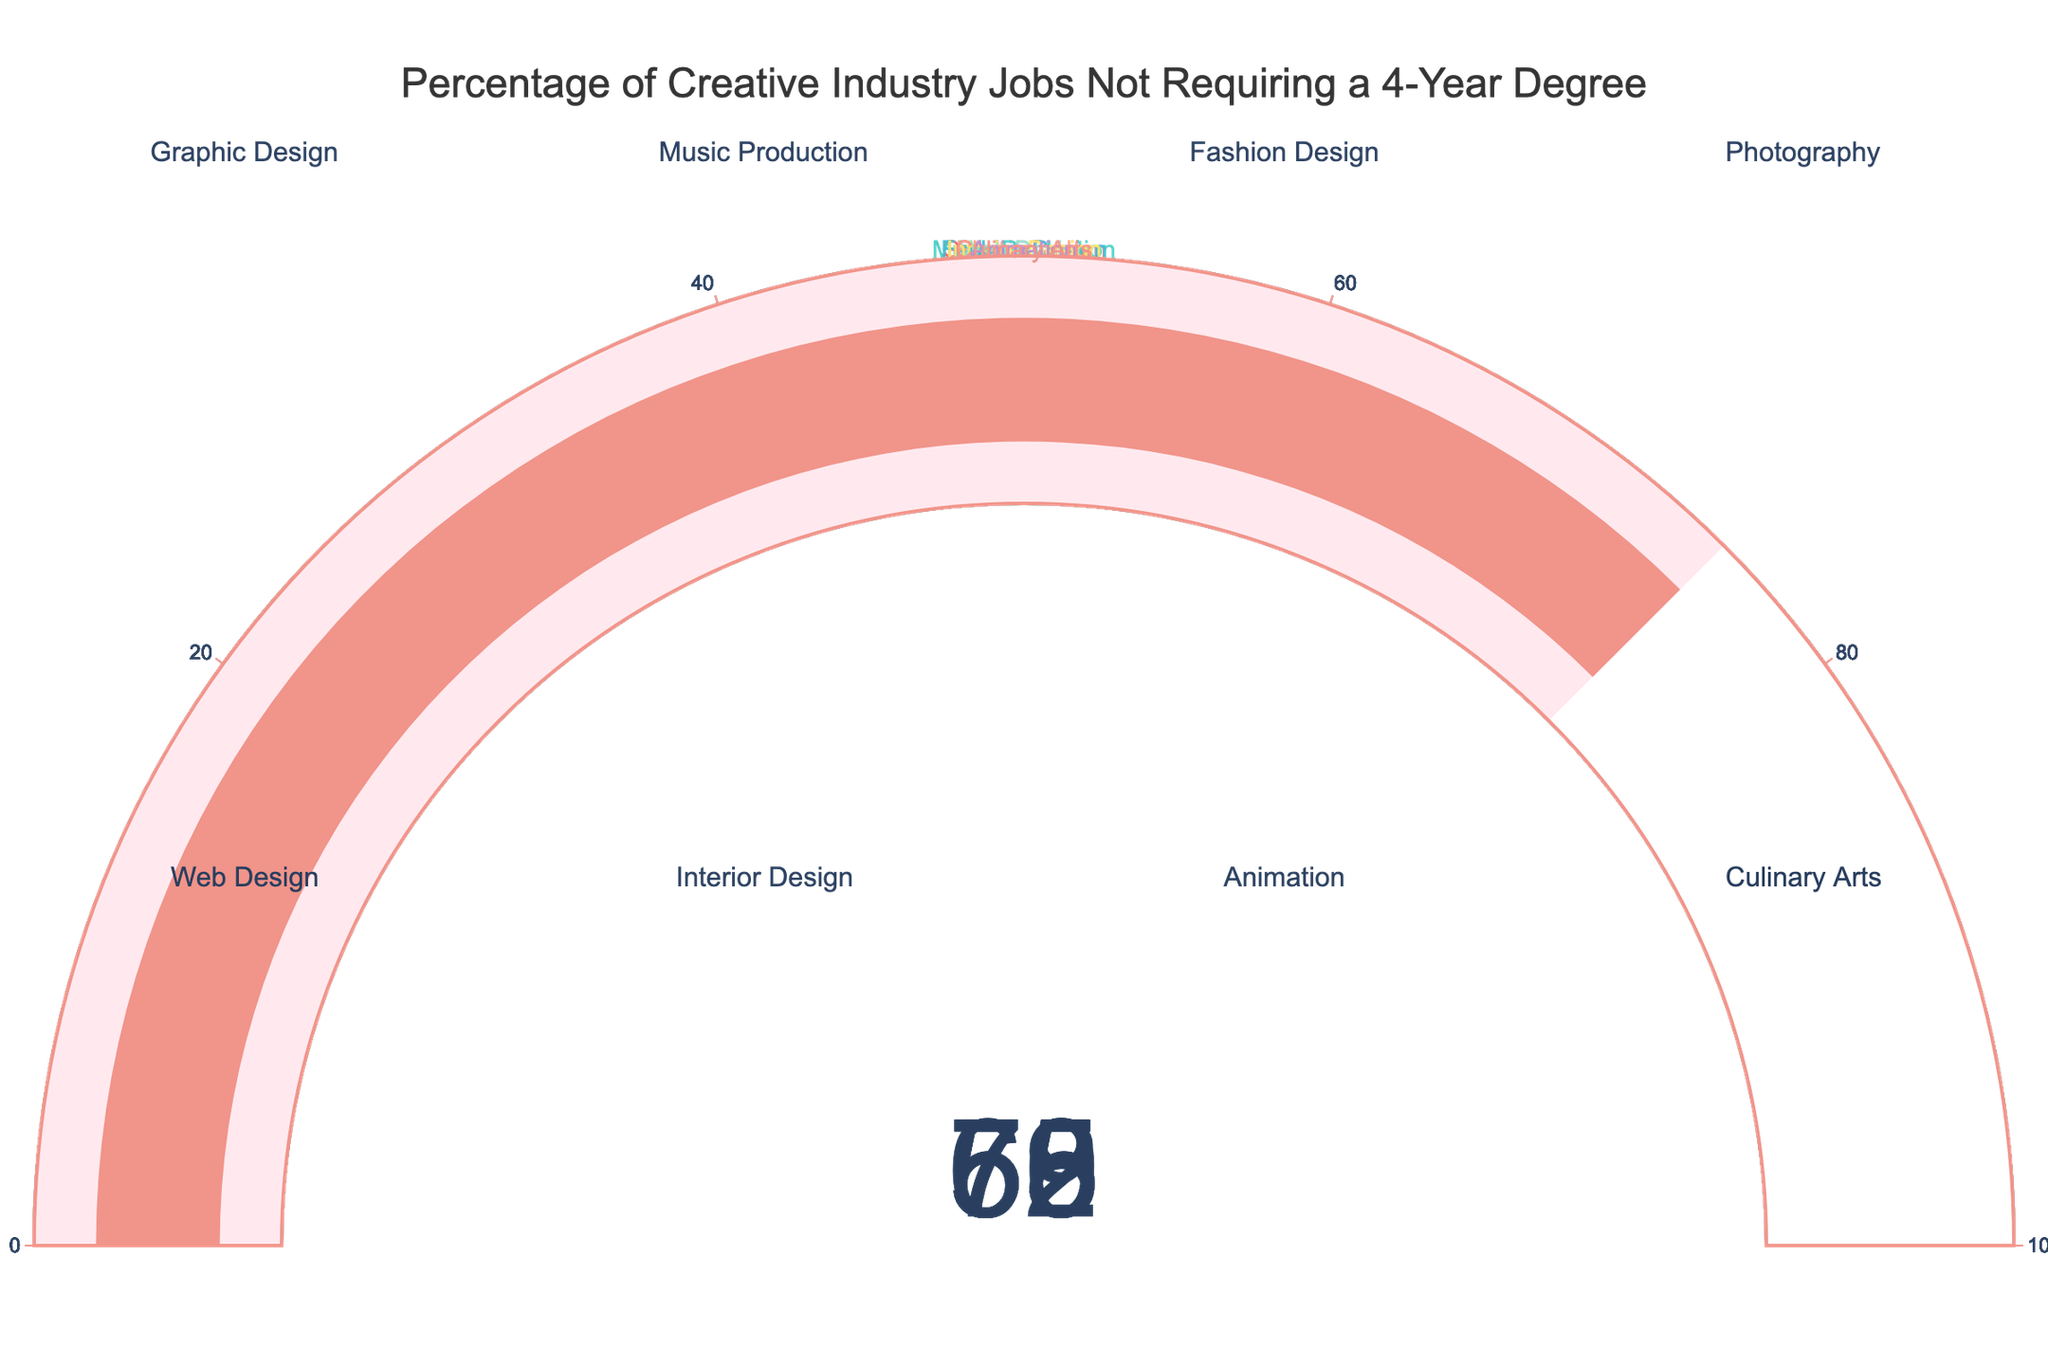What is the title of the figure? The title is displayed at the top-center of the figure in bold letters. It reads "Percentage of Creative Industry Jobs Not Requiring a 4-Year Degree."
Answer: Percentage of Creative Industry Jobs Not Requiring a 4-Year Degree How many creative industry job types are represented in the figure? The figure has 8 gauge charts, each representing a different job type.
Answer: 8 Which job type has the highest percentage of jobs that don't require a 4-year degree? By looking at the values on each gauge, the highest percentage is found in **Culinary Arts** with a value of 75%.
Answer: Culinary Arts What is the lowest percentage shown in the figure and for which job type? The figure shows the lowest value as 53% for Interior Design.
Answer: Interior Design What is the average percentage of jobs that don’t require a 4-year degree across all displayed job types? Adding all percentages (62+58+55+70+65+53+59+75) gives 497. Dividing by 8 (the number of job types) results in 62.125%
Answer: 62.125% Is the percentage of Web Design jobs that don’t require a 4-year degree higher or lower than Animation? Web Design has 65% and Animation has 59%. Since 65% is greater than 59%, Web Design is higher.
Answer: Higher What's the difference in the percentage between Graphic Design and Photography? Graphic Design has 62% and Photography has 70%. The difference is 70% - 62% which equals 8%.
Answer: 8% Which two job types have percentages that are closest to each other? By comparing the differences, Animation (59%) and Music Production (58%) are closest with only a 1% difference.
Answer: Animation and Music Production What's the combined percentage of jobs that don’t require a 4-year degree for Fashion Design and Graphic Design? Adding the percentages of Fashion Design (55%) and Graphic Design (62%) results in 117%.
Answer: 117% Out of the job types listed, which ones have a percentage higher than 60%? By comparing all values, the job types with more than 60% are Graphic Design (62%), Photography (70%), Web Design (65%), Culinary Arts (75%).
Answer: Graphic Design, Photography, Web Design, Culinary Arts 